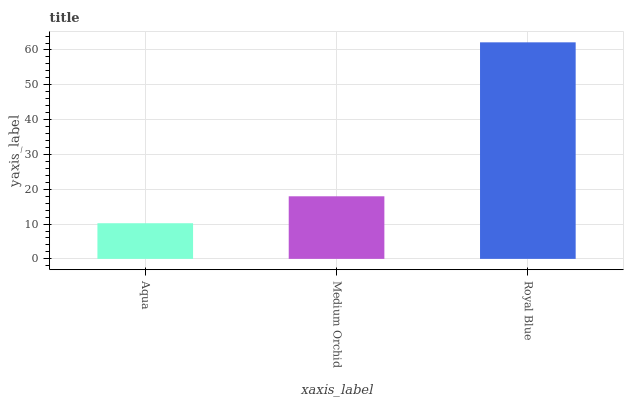Is Aqua the minimum?
Answer yes or no. Yes. Is Royal Blue the maximum?
Answer yes or no. Yes. Is Medium Orchid the minimum?
Answer yes or no. No. Is Medium Orchid the maximum?
Answer yes or no. No. Is Medium Orchid greater than Aqua?
Answer yes or no. Yes. Is Aqua less than Medium Orchid?
Answer yes or no. Yes. Is Aqua greater than Medium Orchid?
Answer yes or no. No. Is Medium Orchid less than Aqua?
Answer yes or no. No. Is Medium Orchid the high median?
Answer yes or no. Yes. Is Medium Orchid the low median?
Answer yes or no. Yes. Is Aqua the high median?
Answer yes or no. No. Is Royal Blue the low median?
Answer yes or no. No. 